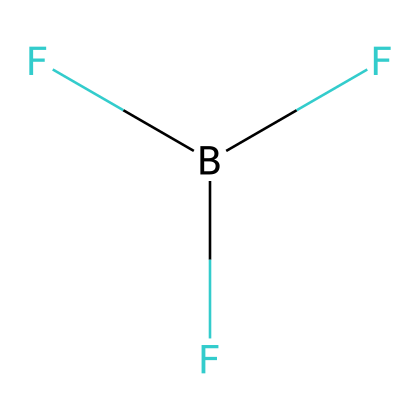What is the chemical name of this structure? The structure consists of a boron atom (B) bonded with three fluorine atoms (F), which corresponds to the chemical name of boron trifluoride.
Answer: boron trifluoride How many fluorine atoms are present in this chemical? By examining the SMILES representation, we see that it includes three fluorine atoms as indicated by the "F" characters following the boron.
Answer: three What type of chemical is boron trifluoride classified as? Boron trifluoride is classified as a Lewis acid because it can accept electron pairs, which is a key characteristic of Lewis acids.
Answer: Lewis acid What is the total number of valence electrons in boron trifluoride? Boron has three valence electrons, and each fluorine atom has seven, resulting in a total of 3 + (3 x 7) = 24 valence electrons.
Answer: twenty-four Is boron trifluoride a polar or nonpolar molecule? The different electronegativities of boron and fluorine create a dipole moment, making the molecule polar.
Answer: polar Why does boron trifluoride act as a Lewis acid? Boron trifluoride can accept an electron pair due to the incomplete octet of boron, making it behave as a Lewis acid in reactions.
Answer: incomplete octet 